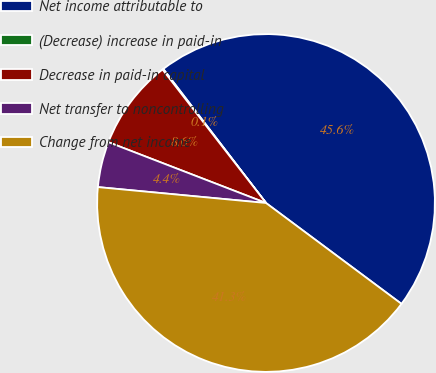Convert chart. <chart><loc_0><loc_0><loc_500><loc_500><pie_chart><fcel>Net income attributable to<fcel>(Decrease) increase in paid-in<fcel>Decrease in paid-in capital<fcel>Net transfer to noncontrolling<fcel>Change from net income<nl><fcel>45.59%<fcel>0.09%<fcel>8.64%<fcel>4.36%<fcel>41.31%<nl></chart> 